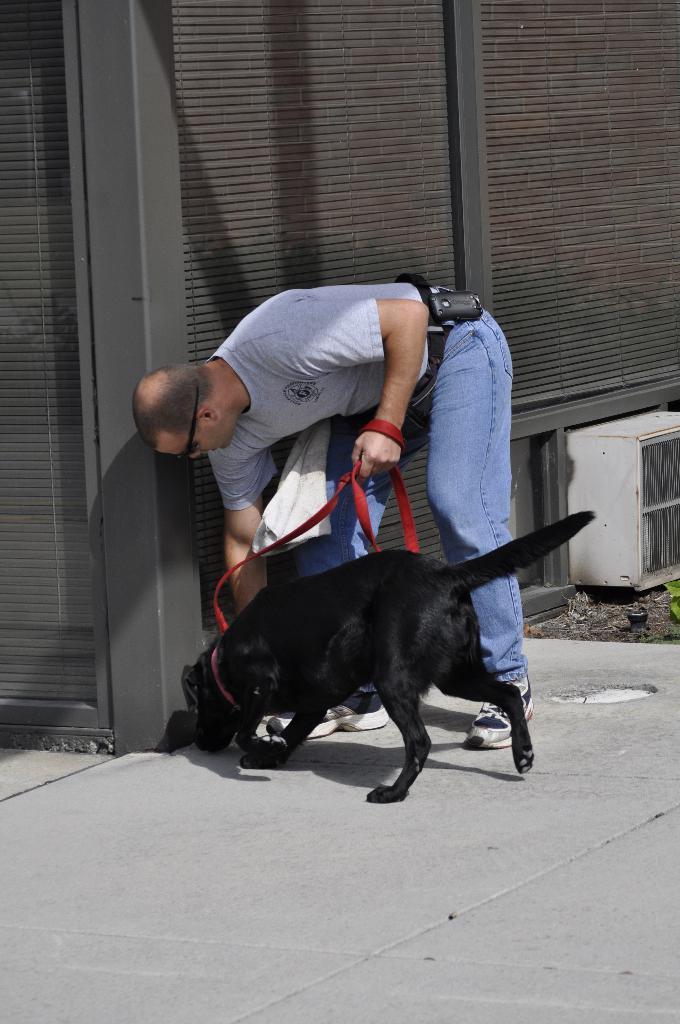Please provide a concise description of this image. Here a man is carrying a dog holding dog belt in his hand. 